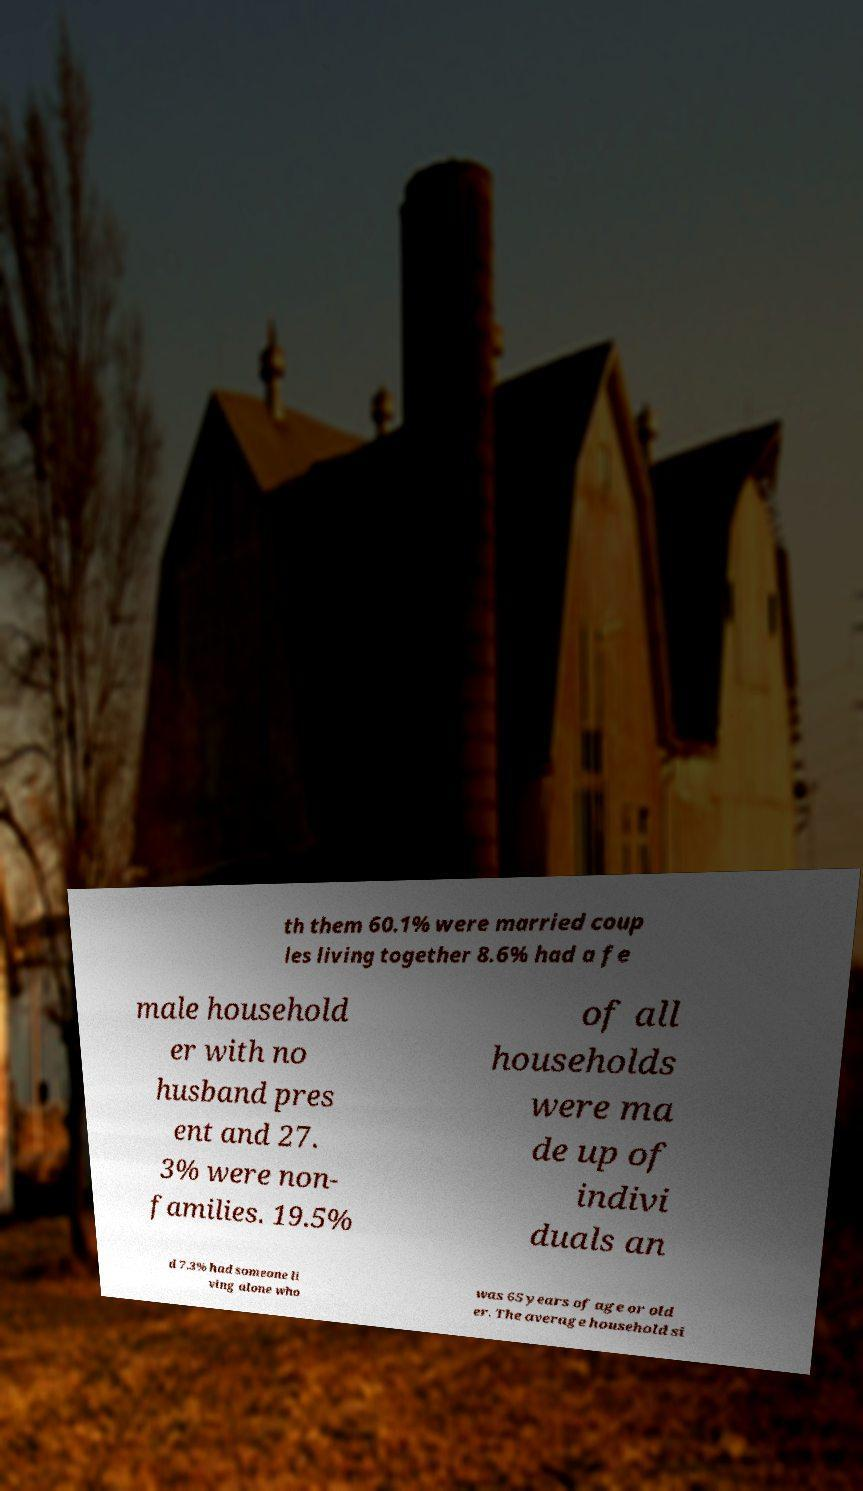There's text embedded in this image that I need extracted. Can you transcribe it verbatim? th them 60.1% were married coup les living together 8.6% had a fe male household er with no husband pres ent and 27. 3% were non- families. 19.5% of all households were ma de up of indivi duals an d 7.3% had someone li ving alone who was 65 years of age or old er. The average household si 